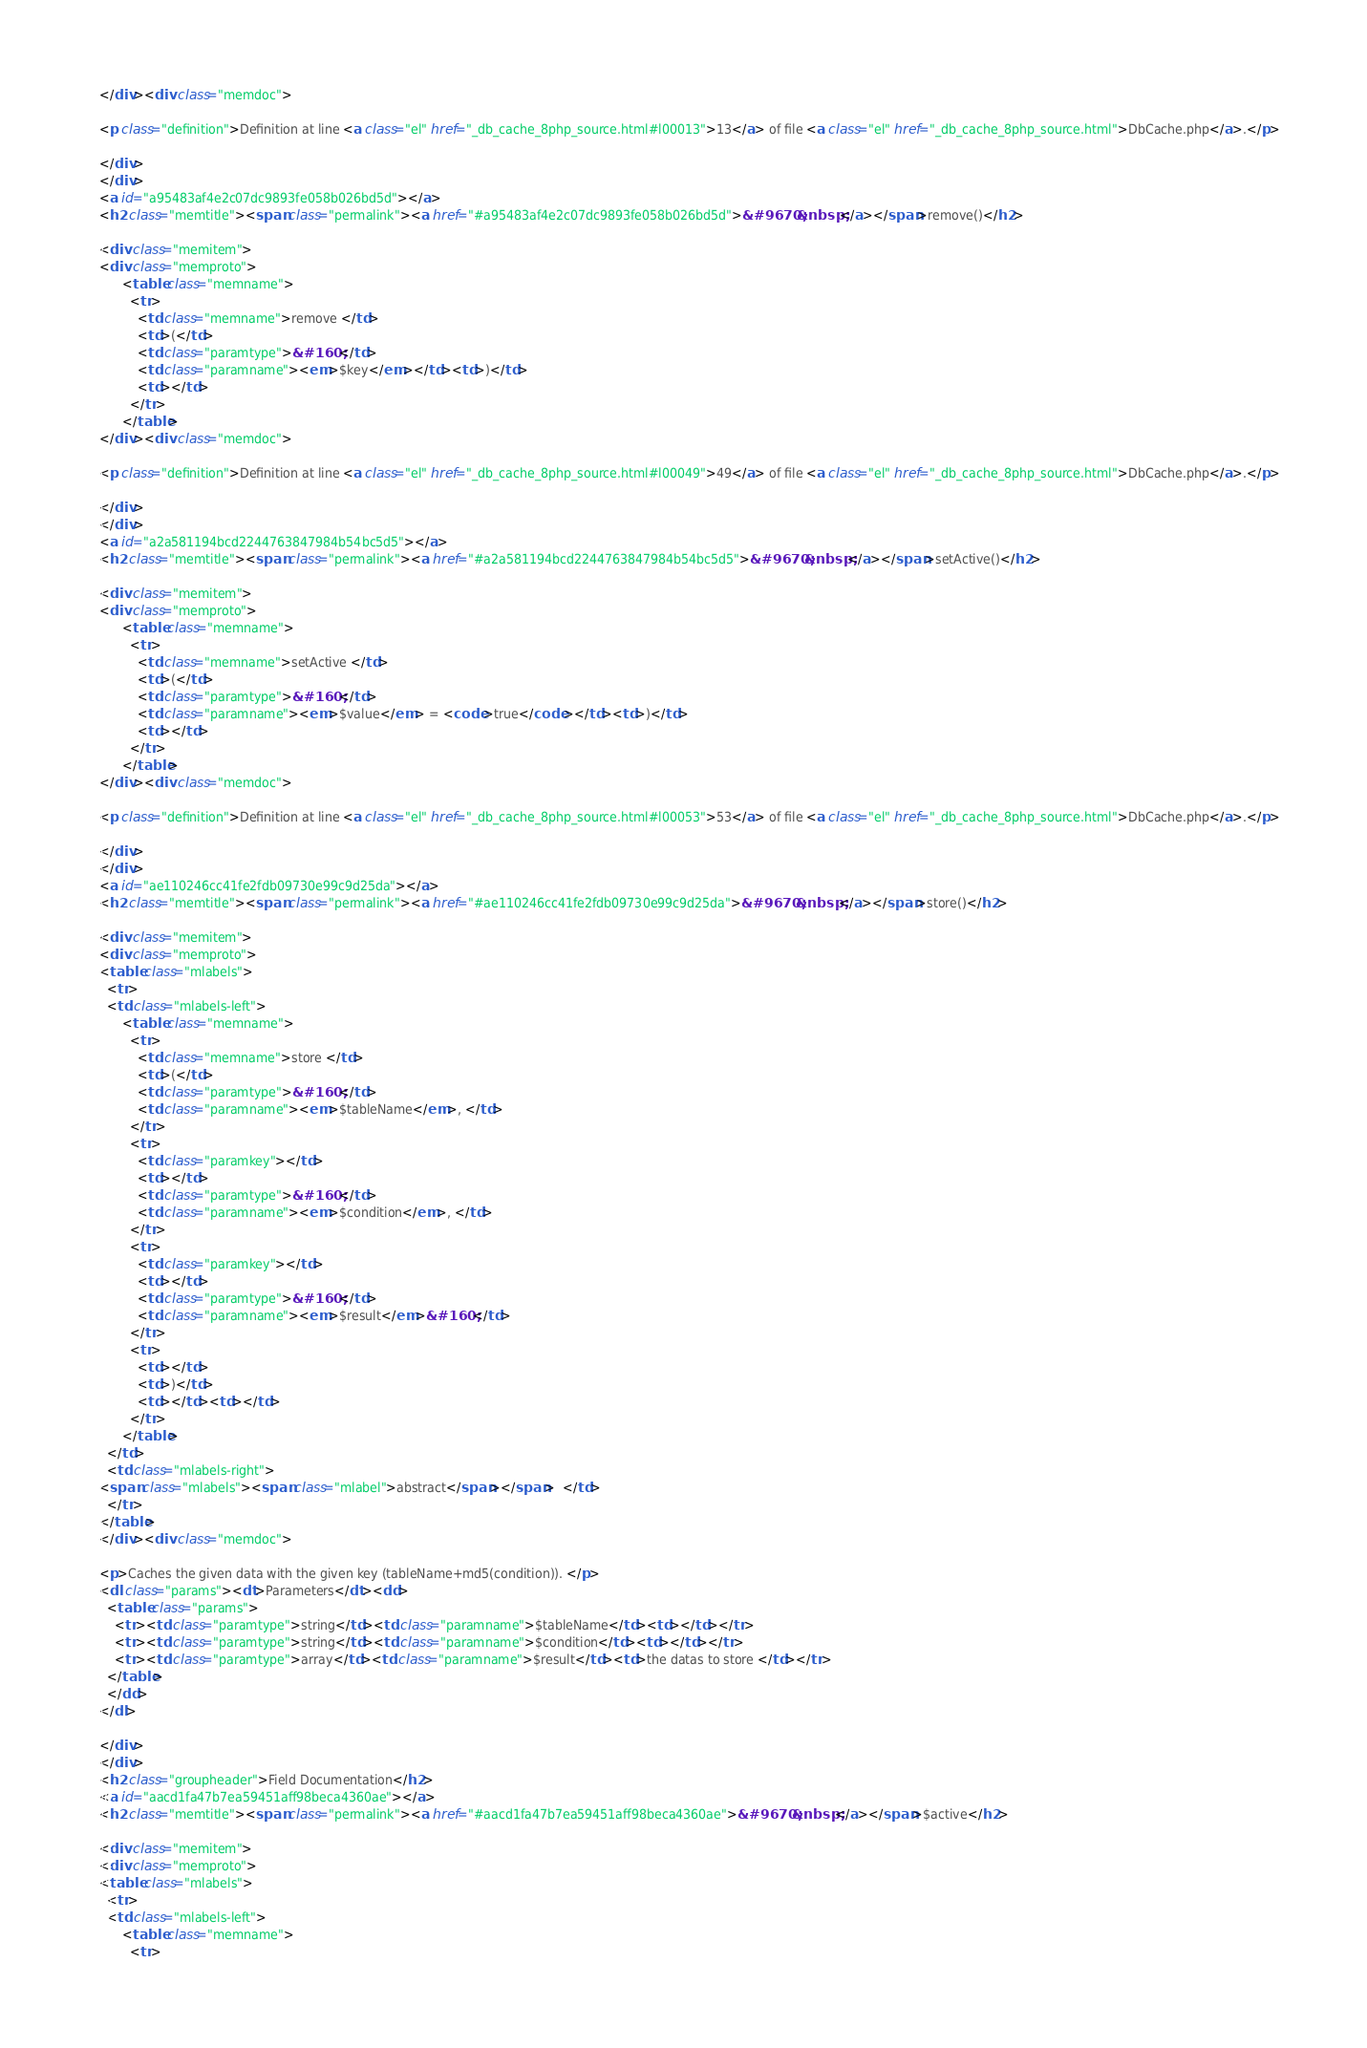Convert code to text. <code><loc_0><loc_0><loc_500><loc_500><_HTML_></div><div class="memdoc">

<p class="definition">Definition at line <a class="el" href="_db_cache_8php_source.html#l00013">13</a> of file <a class="el" href="_db_cache_8php_source.html">DbCache.php</a>.</p>

</div>
</div>
<a id="a95483af4e2c07dc9893fe058b026bd5d"></a>
<h2 class="memtitle"><span class="permalink"><a href="#a95483af4e2c07dc9893fe058b026bd5d">&#9670;&nbsp;</a></span>remove()</h2>

<div class="memitem">
<div class="memproto">
      <table class="memname">
        <tr>
          <td class="memname">remove </td>
          <td>(</td>
          <td class="paramtype">&#160;</td>
          <td class="paramname"><em>$key</em></td><td>)</td>
          <td></td>
        </tr>
      </table>
</div><div class="memdoc">

<p class="definition">Definition at line <a class="el" href="_db_cache_8php_source.html#l00049">49</a> of file <a class="el" href="_db_cache_8php_source.html">DbCache.php</a>.</p>

</div>
</div>
<a id="a2a581194bcd2244763847984b54bc5d5"></a>
<h2 class="memtitle"><span class="permalink"><a href="#a2a581194bcd2244763847984b54bc5d5">&#9670;&nbsp;</a></span>setActive()</h2>

<div class="memitem">
<div class="memproto">
      <table class="memname">
        <tr>
          <td class="memname">setActive </td>
          <td>(</td>
          <td class="paramtype">&#160;</td>
          <td class="paramname"><em>$value</em> = <code>true</code></td><td>)</td>
          <td></td>
        </tr>
      </table>
</div><div class="memdoc">

<p class="definition">Definition at line <a class="el" href="_db_cache_8php_source.html#l00053">53</a> of file <a class="el" href="_db_cache_8php_source.html">DbCache.php</a>.</p>

</div>
</div>
<a id="ae110246cc41fe2fdb09730e99c9d25da"></a>
<h2 class="memtitle"><span class="permalink"><a href="#ae110246cc41fe2fdb09730e99c9d25da">&#9670;&nbsp;</a></span>store()</h2>

<div class="memitem">
<div class="memproto">
<table class="mlabels">
  <tr>
  <td class="mlabels-left">
      <table class="memname">
        <tr>
          <td class="memname">store </td>
          <td>(</td>
          <td class="paramtype">&#160;</td>
          <td class="paramname"><em>$tableName</em>, </td>
        </tr>
        <tr>
          <td class="paramkey"></td>
          <td></td>
          <td class="paramtype">&#160;</td>
          <td class="paramname"><em>$condition</em>, </td>
        </tr>
        <tr>
          <td class="paramkey"></td>
          <td></td>
          <td class="paramtype">&#160;</td>
          <td class="paramname"><em>$result</em>&#160;</td>
        </tr>
        <tr>
          <td></td>
          <td>)</td>
          <td></td><td></td>
        </tr>
      </table>
  </td>
  <td class="mlabels-right">
<span class="mlabels"><span class="mlabel">abstract</span></span>  </td>
  </tr>
</table>
</div><div class="memdoc">

<p>Caches the given data with the given key (tableName+md5(condition)). </p>
<dl class="params"><dt>Parameters</dt><dd>
  <table class="params">
    <tr><td class="paramtype">string</td><td class="paramname">$tableName</td><td></td></tr>
    <tr><td class="paramtype">string</td><td class="paramname">$condition</td><td></td></tr>
    <tr><td class="paramtype">array</td><td class="paramname">$result</td><td>the datas to store </td></tr>
  </table>
  </dd>
</dl>

</div>
</div>
<h2 class="groupheader">Field Documentation</h2>
<a id="aacd1fa47b7ea59451aff98beca4360ae"></a>
<h2 class="memtitle"><span class="permalink"><a href="#aacd1fa47b7ea59451aff98beca4360ae">&#9670;&nbsp;</a></span>$active</h2>

<div class="memitem">
<div class="memproto">
<table class="mlabels">
  <tr>
  <td class="mlabels-left">
      <table class="memname">
        <tr></code> 